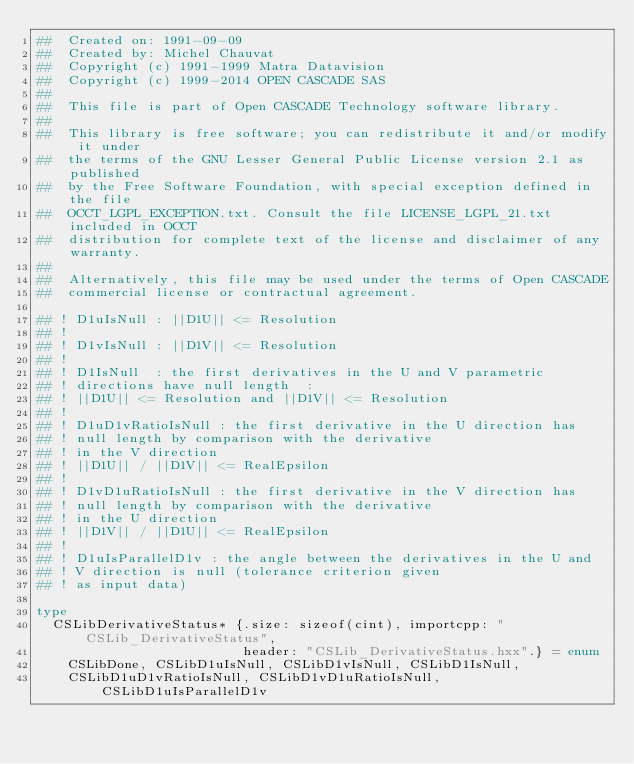<code> <loc_0><loc_0><loc_500><loc_500><_Nim_>##  Created on: 1991-09-09
##  Created by: Michel Chauvat
##  Copyright (c) 1991-1999 Matra Datavision
##  Copyright (c) 1999-2014 OPEN CASCADE SAS
##
##  This file is part of Open CASCADE Technology software library.
##
##  This library is free software; you can redistribute it and/or modify it under
##  the terms of the GNU Lesser General Public License version 2.1 as published
##  by the Free Software Foundation, with special exception defined in the file
##  OCCT_LGPL_EXCEPTION.txt. Consult the file LICENSE_LGPL_21.txt included in OCCT
##  distribution for complete text of the license and disclaimer of any warranty.
##
##  Alternatively, this file may be used under the terms of Open CASCADE
##  commercial license or contractual agreement.

## ! D1uIsNull : ||D1U|| <= Resolution
## !
## ! D1vIsNull : ||D1V|| <= Resolution
## !
## ! D1IsNull  : the first derivatives in the U and V parametric
## ! directions have null length  :
## ! ||D1U|| <= Resolution and ||D1V|| <= Resolution
## !
## ! D1uD1vRatioIsNull : the first derivative in the U direction has
## ! null length by comparison with the derivative
## ! in the V direction
## ! ||D1U|| / ||D1V|| <= RealEpsilon
## !
## ! D1vD1uRatioIsNull : the first derivative in the V direction has
## ! null length by comparison with the derivative
## ! in the U direction
## ! ||D1V|| / ||D1U|| <= RealEpsilon
## !
## ! D1uIsParallelD1v : the angle between the derivatives in the U and
## ! V direction is null (tolerance criterion given
## ! as input data)

type
  CSLibDerivativeStatus* {.size: sizeof(cint), importcpp: "CSLib_DerivativeStatus",
                          header: "CSLib_DerivativeStatus.hxx".} = enum
    CSLibDone, CSLibD1uIsNull, CSLibD1vIsNull, CSLibD1IsNull,
    CSLibD1uD1vRatioIsNull, CSLibD1vD1uRatioIsNull, CSLibD1uIsParallelD1v



























</code> 